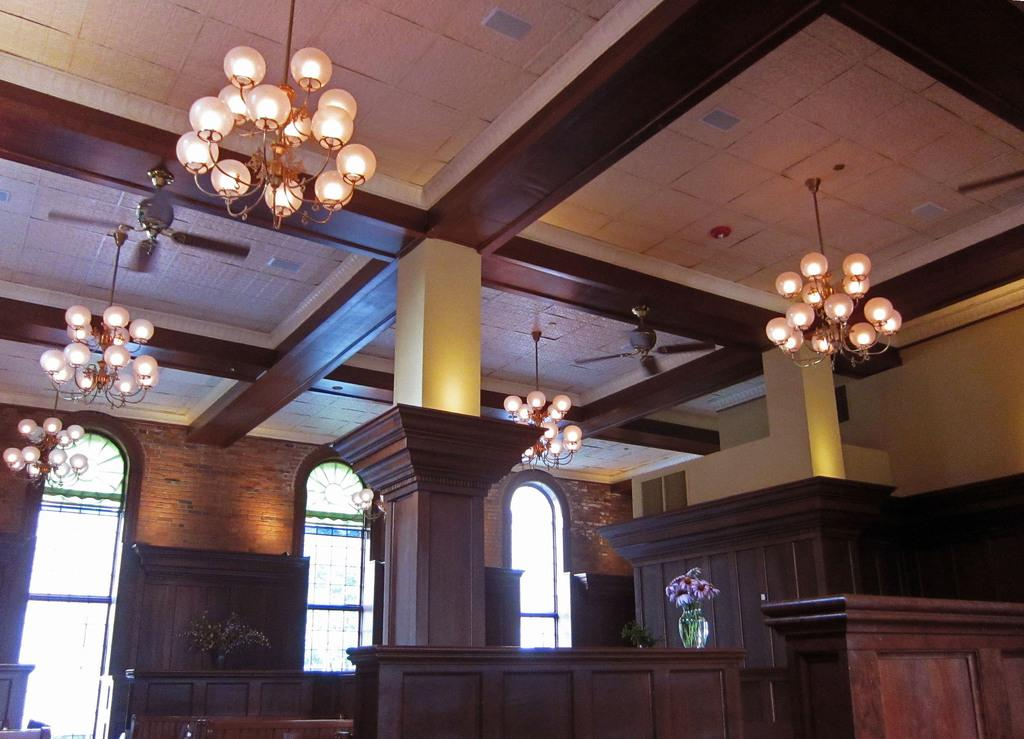What can be seen in the image that provides illumination? There are lights in the image. What architectural feature is present in the image? There is a pillar in the image. What piece of furniture is in the image? There is a table in the image. What decorative item is present in the image? There is a flower vase in the image. What type of structure is visible in the image? There is a wall in the image. What allows natural light to enter the space in the image? There are windows in the image. What type of fruit is being harvested by the cook in the image? There is no cook or fruit harvesting present in the image. How many cherries are on the plough in the image? There is no plough or cherries present in the image. 